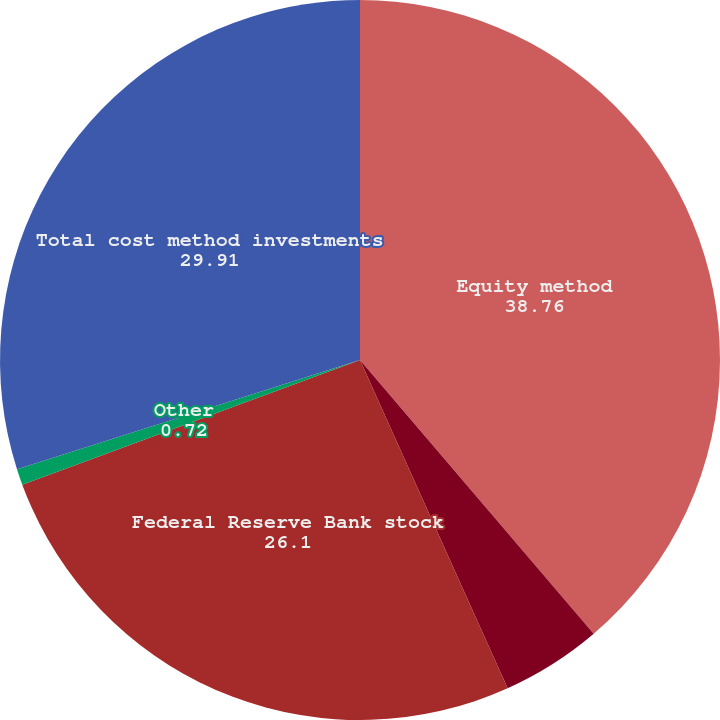Convert chart to OTSL. <chart><loc_0><loc_0><loc_500><loc_500><pie_chart><fcel>Equity method<fcel>Deferred compensation plan<fcel>Federal Reserve Bank stock<fcel>Other<fcel>Total cost method investments<nl><fcel>38.76%<fcel>4.52%<fcel>26.1%<fcel>0.72%<fcel>29.91%<nl></chart> 